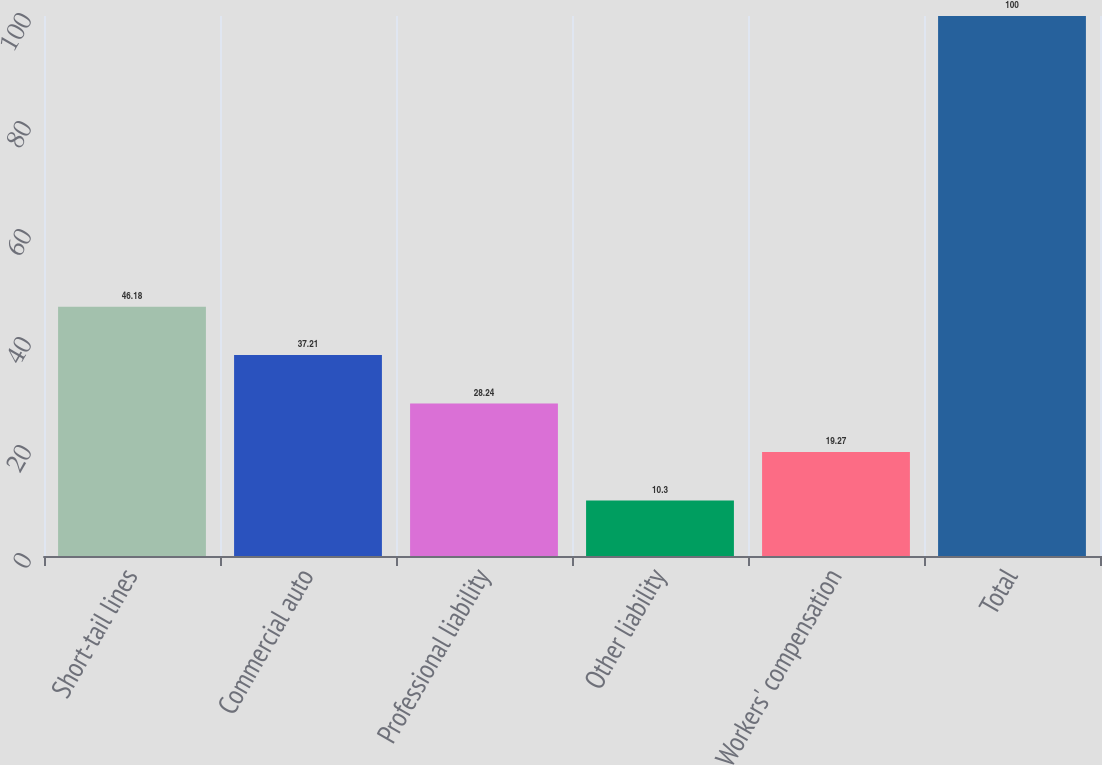<chart> <loc_0><loc_0><loc_500><loc_500><bar_chart><fcel>Short-tail lines<fcel>Commercial auto<fcel>Professional liability<fcel>Other liability<fcel>Workers' compensation<fcel>Total<nl><fcel>46.18<fcel>37.21<fcel>28.24<fcel>10.3<fcel>19.27<fcel>100<nl></chart> 